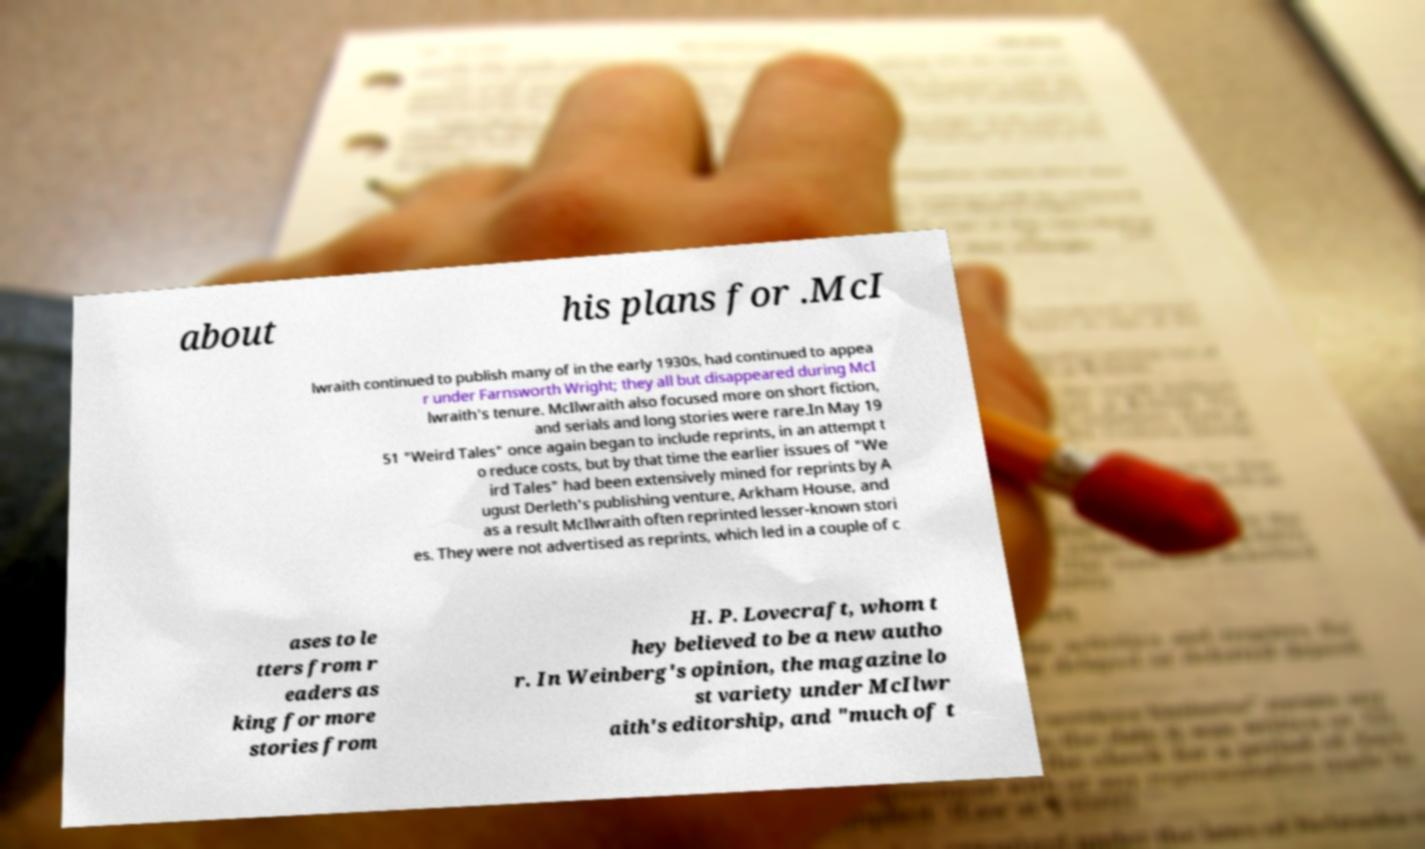I need the written content from this picture converted into text. Can you do that? about his plans for .McI lwraith continued to publish many of in the early 1930s, had continued to appea r under Farnsworth Wright; they all but disappeared during McI lwraith's tenure. McIlwraith also focused more on short fiction, and serials and long stories were rare.In May 19 51 "Weird Tales" once again began to include reprints, in an attempt t o reduce costs, but by that time the earlier issues of "We ird Tales" had been extensively mined for reprints by A ugust Derleth's publishing venture, Arkham House, and as a result McIlwraith often reprinted lesser-known stori es. They were not advertised as reprints, which led in a couple of c ases to le tters from r eaders as king for more stories from H. P. Lovecraft, whom t hey believed to be a new autho r. In Weinberg's opinion, the magazine lo st variety under McIlwr aith's editorship, and "much of t 